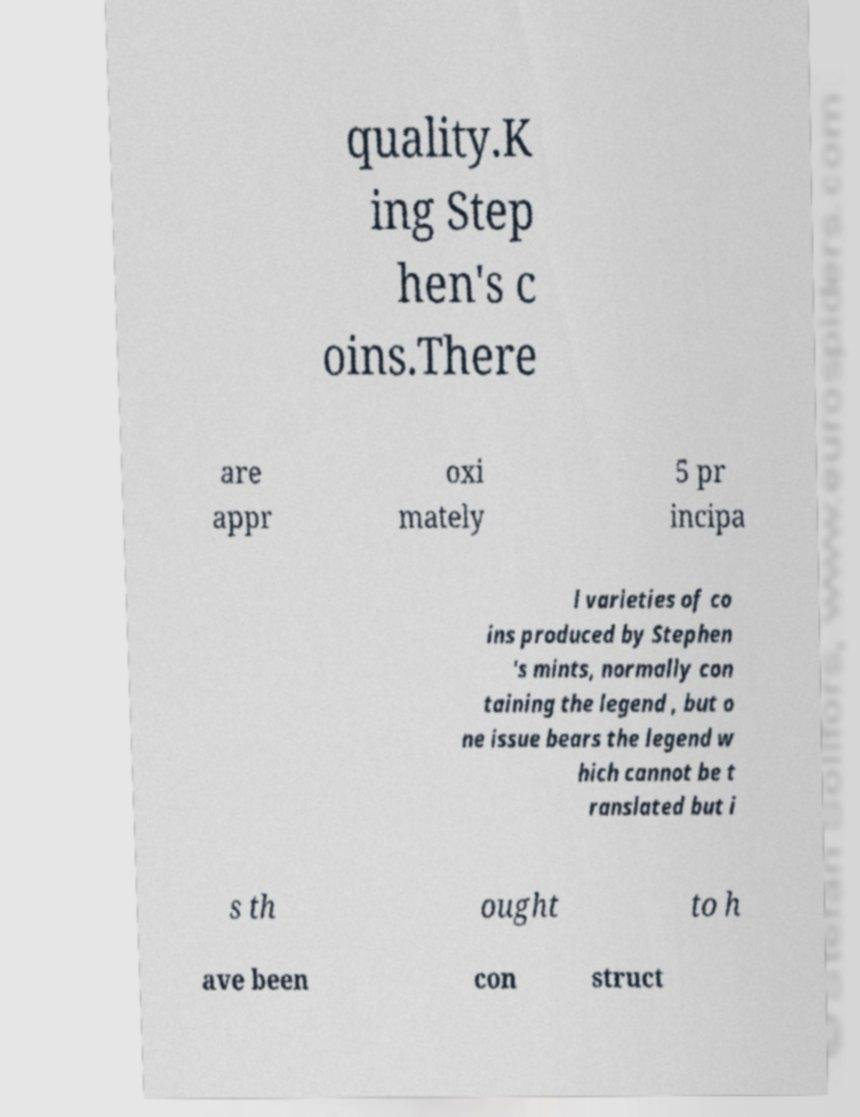What messages or text are displayed in this image? I need them in a readable, typed format. quality.K ing Step hen's c oins.There are appr oxi mately 5 pr incipa l varieties of co ins produced by Stephen 's mints, normally con taining the legend , but o ne issue bears the legend w hich cannot be t ranslated but i s th ought to h ave been con struct 